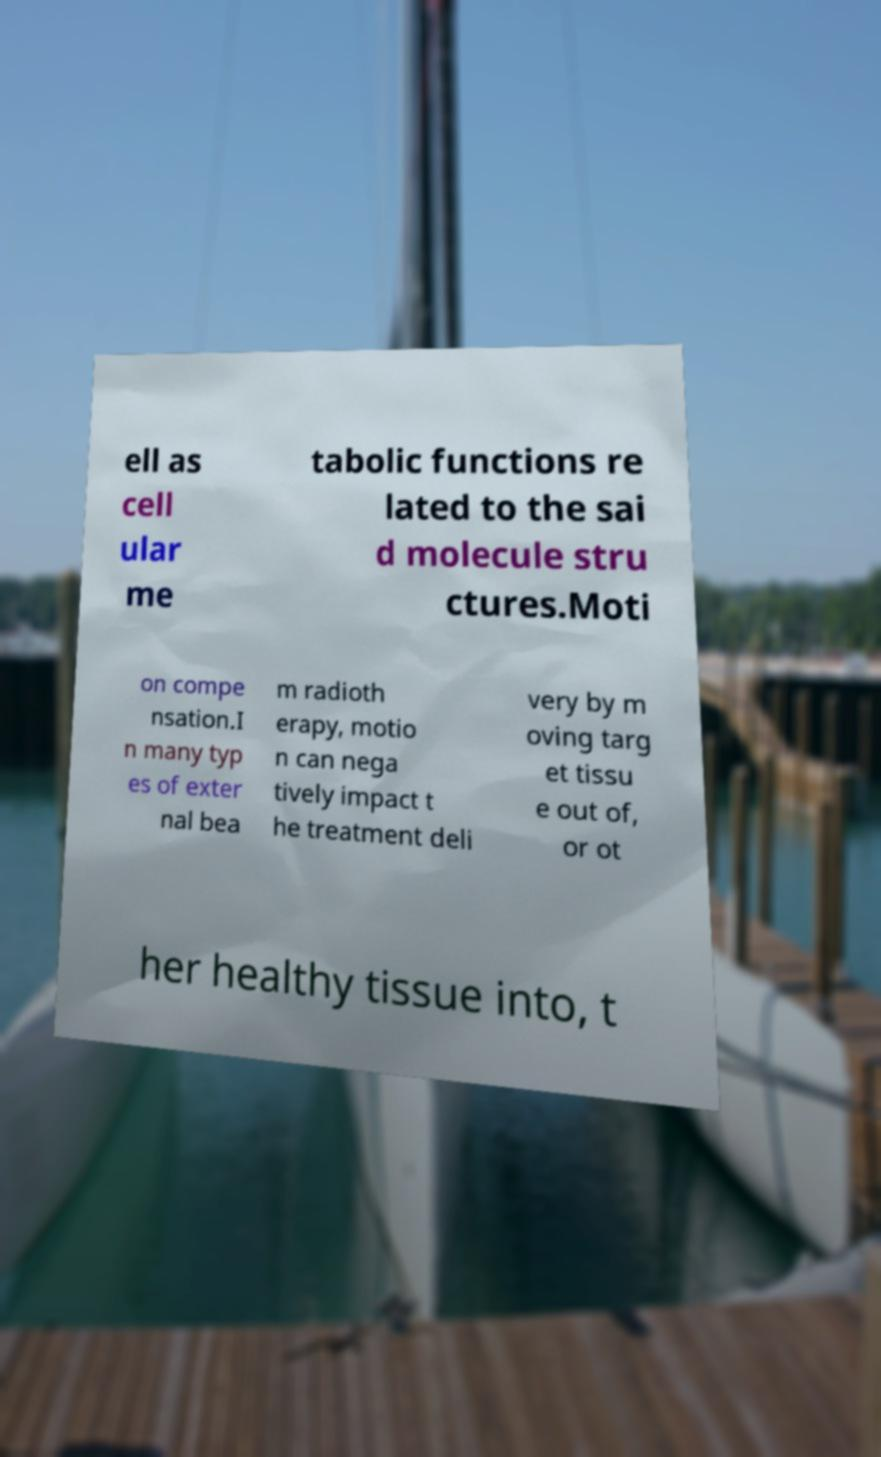Can you accurately transcribe the text from the provided image for me? ell as cell ular me tabolic functions re lated to the sai d molecule stru ctures.Moti on compe nsation.I n many typ es of exter nal bea m radioth erapy, motio n can nega tively impact t he treatment deli very by m oving targ et tissu e out of, or ot her healthy tissue into, t 